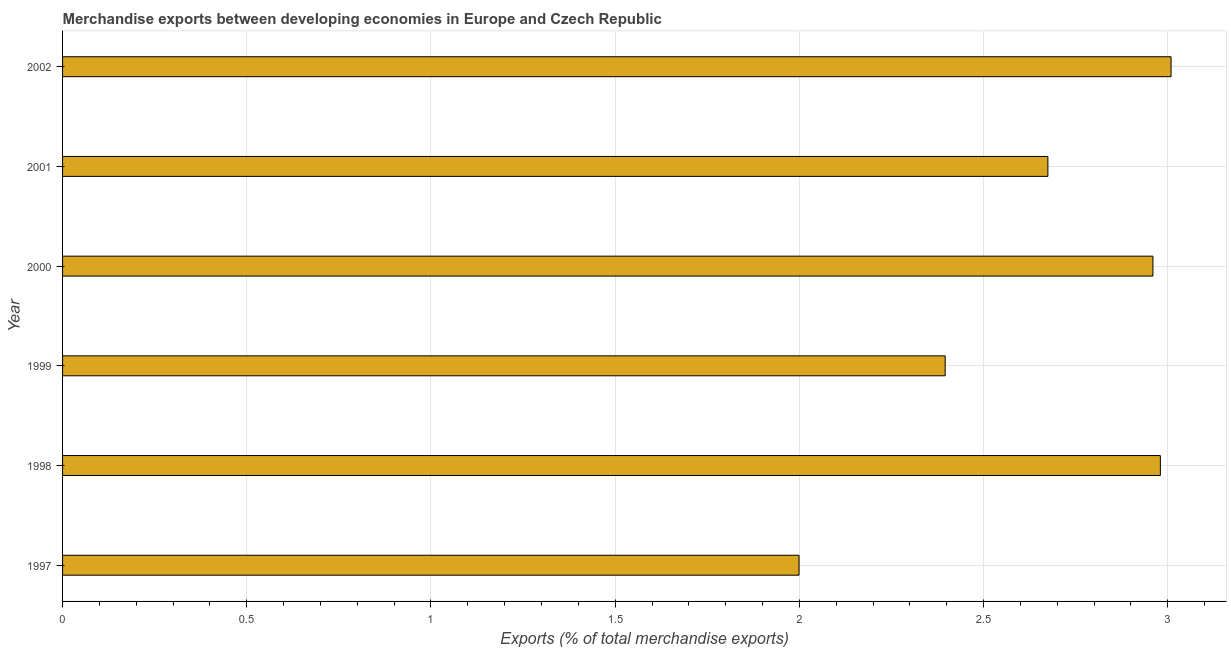Does the graph contain any zero values?
Offer a terse response. No. Does the graph contain grids?
Provide a succinct answer. Yes. What is the title of the graph?
Keep it short and to the point. Merchandise exports between developing economies in Europe and Czech Republic. What is the label or title of the X-axis?
Make the answer very short. Exports (% of total merchandise exports). What is the merchandise exports in 2002?
Make the answer very short. 3.01. Across all years, what is the maximum merchandise exports?
Provide a short and direct response. 3.01. Across all years, what is the minimum merchandise exports?
Make the answer very short. 2. In which year was the merchandise exports maximum?
Your answer should be compact. 2002. What is the sum of the merchandise exports?
Offer a very short reply. 16.02. What is the difference between the merchandise exports in 1999 and 2001?
Your answer should be very brief. -0.28. What is the average merchandise exports per year?
Provide a short and direct response. 2.67. What is the median merchandise exports?
Provide a succinct answer. 2.82. In how many years, is the merchandise exports greater than 1.9 %?
Keep it short and to the point. 6. What is the ratio of the merchandise exports in 1999 to that in 2002?
Give a very brief answer. 0.8. What is the difference between the highest and the second highest merchandise exports?
Provide a succinct answer. 0.03. Is the sum of the merchandise exports in 1998 and 2002 greater than the maximum merchandise exports across all years?
Offer a very short reply. Yes. Are all the bars in the graph horizontal?
Ensure brevity in your answer.  Yes. What is the difference between two consecutive major ticks on the X-axis?
Provide a short and direct response. 0.5. What is the Exports (% of total merchandise exports) in 1997?
Make the answer very short. 2. What is the Exports (% of total merchandise exports) of 1998?
Give a very brief answer. 2.98. What is the Exports (% of total merchandise exports) of 1999?
Make the answer very short. 2.4. What is the Exports (% of total merchandise exports) in 2000?
Give a very brief answer. 2.96. What is the Exports (% of total merchandise exports) of 2001?
Your answer should be compact. 2.67. What is the Exports (% of total merchandise exports) in 2002?
Offer a terse response. 3.01. What is the difference between the Exports (% of total merchandise exports) in 1997 and 1998?
Ensure brevity in your answer.  -0.98. What is the difference between the Exports (% of total merchandise exports) in 1997 and 1999?
Give a very brief answer. -0.4. What is the difference between the Exports (% of total merchandise exports) in 1997 and 2000?
Give a very brief answer. -0.96. What is the difference between the Exports (% of total merchandise exports) in 1997 and 2001?
Your answer should be very brief. -0.68. What is the difference between the Exports (% of total merchandise exports) in 1997 and 2002?
Your answer should be compact. -1.01. What is the difference between the Exports (% of total merchandise exports) in 1998 and 1999?
Your answer should be very brief. 0.58. What is the difference between the Exports (% of total merchandise exports) in 1998 and 2000?
Your answer should be very brief. 0.02. What is the difference between the Exports (% of total merchandise exports) in 1998 and 2001?
Your answer should be very brief. 0.31. What is the difference between the Exports (% of total merchandise exports) in 1998 and 2002?
Provide a succinct answer. -0.03. What is the difference between the Exports (% of total merchandise exports) in 1999 and 2000?
Provide a succinct answer. -0.56. What is the difference between the Exports (% of total merchandise exports) in 1999 and 2001?
Your answer should be very brief. -0.28. What is the difference between the Exports (% of total merchandise exports) in 1999 and 2002?
Your response must be concise. -0.61. What is the difference between the Exports (% of total merchandise exports) in 2000 and 2001?
Give a very brief answer. 0.29. What is the difference between the Exports (% of total merchandise exports) in 2000 and 2002?
Ensure brevity in your answer.  -0.05. What is the difference between the Exports (% of total merchandise exports) in 2001 and 2002?
Your answer should be very brief. -0.33. What is the ratio of the Exports (% of total merchandise exports) in 1997 to that in 1998?
Your response must be concise. 0.67. What is the ratio of the Exports (% of total merchandise exports) in 1997 to that in 1999?
Your answer should be very brief. 0.83. What is the ratio of the Exports (% of total merchandise exports) in 1997 to that in 2000?
Give a very brief answer. 0.68. What is the ratio of the Exports (% of total merchandise exports) in 1997 to that in 2001?
Ensure brevity in your answer.  0.75. What is the ratio of the Exports (% of total merchandise exports) in 1997 to that in 2002?
Make the answer very short. 0.66. What is the ratio of the Exports (% of total merchandise exports) in 1998 to that in 1999?
Your answer should be very brief. 1.24. What is the ratio of the Exports (% of total merchandise exports) in 1998 to that in 2001?
Your response must be concise. 1.11. What is the ratio of the Exports (% of total merchandise exports) in 1999 to that in 2000?
Your answer should be compact. 0.81. What is the ratio of the Exports (% of total merchandise exports) in 1999 to that in 2001?
Give a very brief answer. 0.9. What is the ratio of the Exports (% of total merchandise exports) in 1999 to that in 2002?
Provide a succinct answer. 0.8. What is the ratio of the Exports (% of total merchandise exports) in 2000 to that in 2001?
Your answer should be very brief. 1.11. What is the ratio of the Exports (% of total merchandise exports) in 2001 to that in 2002?
Your answer should be very brief. 0.89. 